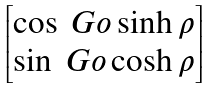Convert formula to latex. <formula><loc_0><loc_0><loc_500><loc_500>\begin{bmatrix} \cos { \ G o } \sinh { \rho } \\ \sin { \ G o } \cosh { \rho } \end{bmatrix}</formula> 